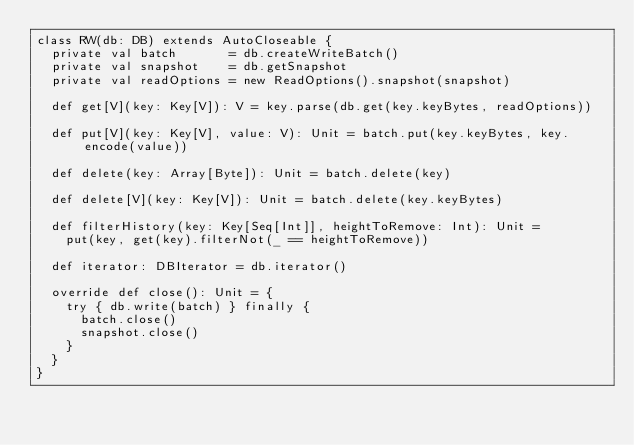<code> <loc_0><loc_0><loc_500><loc_500><_Scala_>class RW(db: DB) extends AutoCloseable {
  private val batch       = db.createWriteBatch()
  private val snapshot    = db.getSnapshot
  private val readOptions = new ReadOptions().snapshot(snapshot)

  def get[V](key: Key[V]): V = key.parse(db.get(key.keyBytes, readOptions))

  def put[V](key: Key[V], value: V): Unit = batch.put(key.keyBytes, key.encode(value))

  def delete(key: Array[Byte]): Unit = batch.delete(key)

  def delete[V](key: Key[V]): Unit = batch.delete(key.keyBytes)

  def filterHistory(key: Key[Seq[Int]], heightToRemove: Int): Unit =
    put(key, get(key).filterNot(_ == heightToRemove))

  def iterator: DBIterator = db.iterator()

  override def close(): Unit = {
    try { db.write(batch) } finally {
      batch.close()
      snapshot.close()
    }
  }
}
</code> 